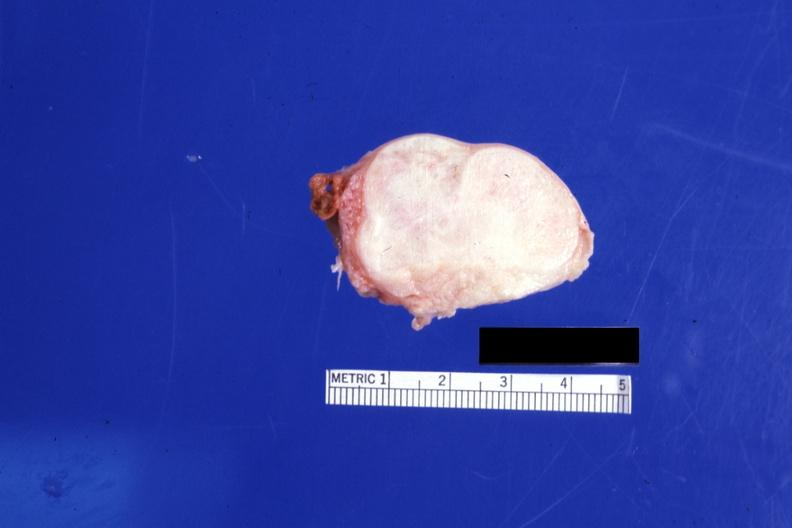s fibroma present?
Answer the question using a single word or phrase. Yes 